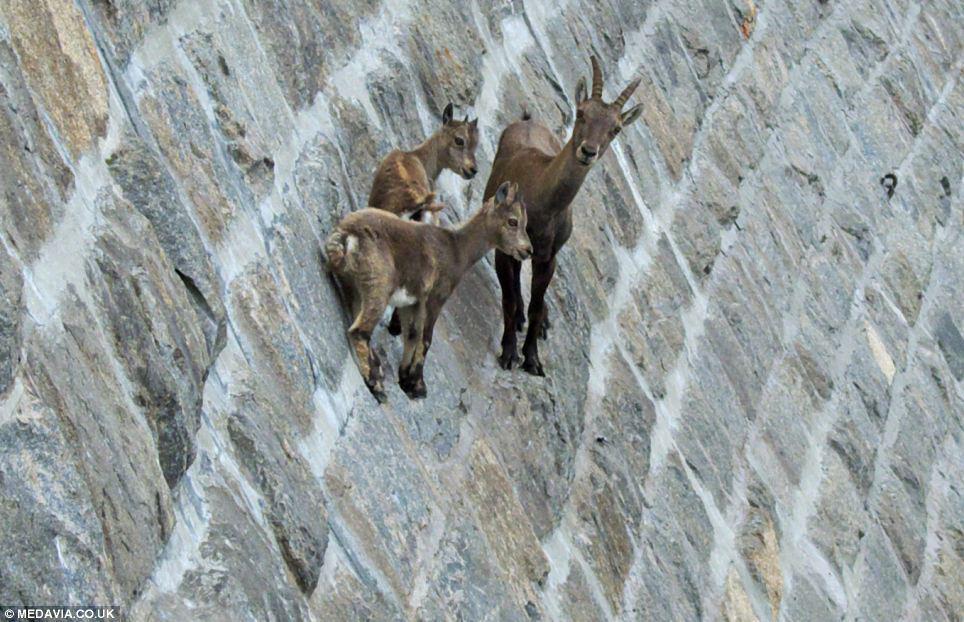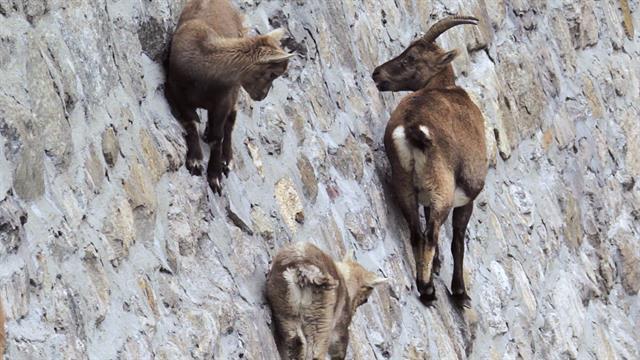The first image is the image on the left, the second image is the image on the right. Given the left and right images, does the statement "At least one image in each pair has exactly three animals together on a wall." hold true? Answer yes or no. Yes. 